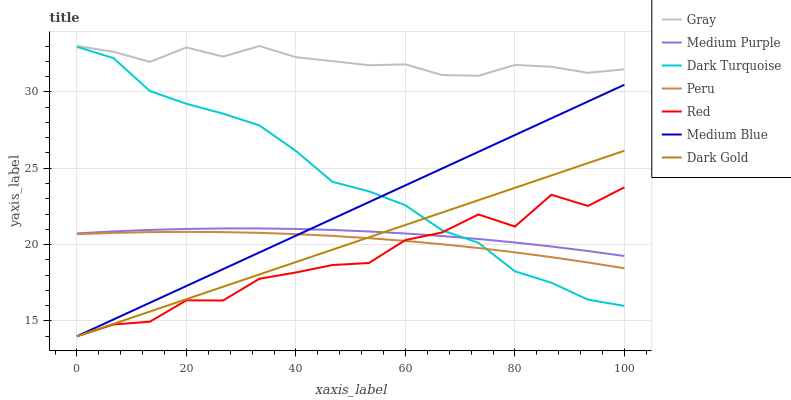Does Dark Gold have the minimum area under the curve?
Answer yes or no. No. Does Dark Gold have the maximum area under the curve?
Answer yes or no. No. Is Dark Gold the smoothest?
Answer yes or no. No. Is Dark Gold the roughest?
Answer yes or no. No. Does Dark Turquoise have the lowest value?
Answer yes or no. No. Does Dark Gold have the highest value?
Answer yes or no. No. Is Dark Turquoise less than Gray?
Answer yes or no. Yes. Is Gray greater than Dark Turquoise?
Answer yes or no. Yes. Does Dark Turquoise intersect Gray?
Answer yes or no. No. 